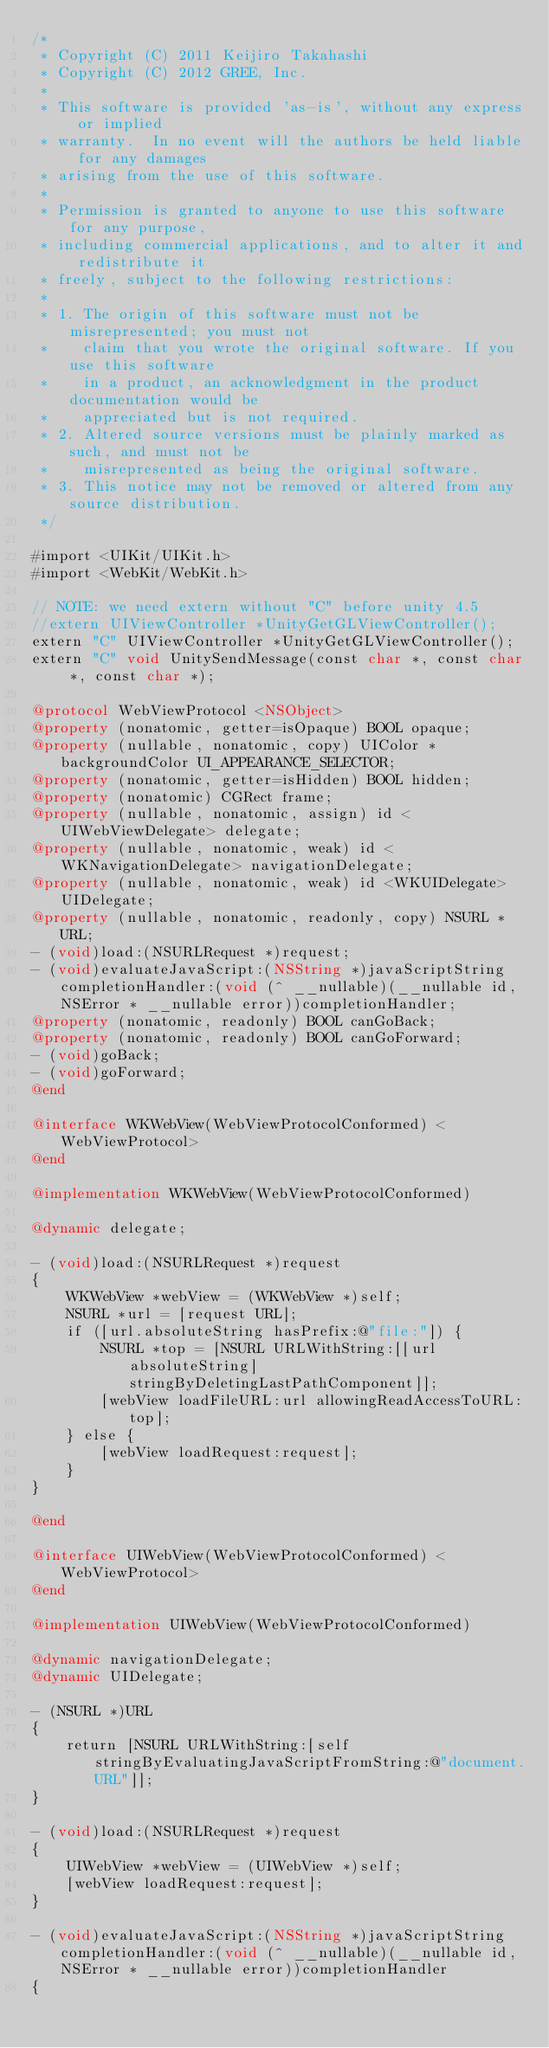Convert code to text. <code><loc_0><loc_0><loc_500><loc_500><_ObjectiveC_>/*
 * Copyright (C) 2011 Keijiro Takahashi
 * Copyright (C) 2012 GREE, Inc.
 *
 * This software is provided 'as-is', without any express or implied
 * warranty.  In no event will the authors be held liable for any damages
 * arising from the use of this software.
 *
 * Permission is granted to anyone to use this software for any purpose,
 * including commercial applications, and to alter it and redistribute it
 * freely, subject to the following restrictions:
 *
 * 1. The origin of this software must not be misrepresented; you must not
 *    claim that you wrote the original software. If you use this software
 *    in a product, an acknowledgment in the product documentation would be
 *    appreciated but is not required.
 * 2. Altered source versions must be plainly marked as such, and must not be
 *    misrepresented as being the original software.
 * 3. This notice may not be removed or altered from any source distribution.
 */

#import <UIKit/UIKit.h>
#import <WebKit/WebKit.h>

// NOTE: we need extern without "C" before unity 4.5
//extern UIViewController *UnityGetGLViewController();
extern "C" UIViewController *UnityGetGLViewController();
extern "C" void UnitySendMessage(const char *, const char *, const char *);

@protocol WebViewProtocol <NSObject>
@property (nonatomic, getter=isOpaque) BOOL opaque;
@property (nullable, nonatomic, copy) UIColor *backgroundColor UI_APPEARANCE_SELECTOR;
@property (nonatomic, getter=isHidden) BOOL hidden;
@property (nonatomic) CGRect frame;
@property (nullable, nonatomic, assign) id <UIWebViewDelegate> delegate;
@property (nullable, nonatomic, weak) id <WKNavigationDelegate> navigationDelegate;
@property (nullable, nonatomic, weak) id <WKUIDelegate> UIDelegate;
@property (nullable, nonatomic, readonly, copy) NSURL *URL;
- (void)load:(NSURLRequest *)request;
- (void)evaluateJavaScript:(NSString *)javaScriptString completionHandler:(void (^ __nullable)(__nullable id, NSError * __nullable error))completionHandler;
@property (nonatomic, readonly) BOOL canGoBack;
@property (nonatomic, readonly) BOOL canGoForward;
- (void)goBack;
- (void)goForward;
@end

@interface WKWebView(WebViewProtocolConformed) <WebViewProtocol>
@end

@implementation WKWebView(WebViewProtocolConformed)

@dynamic delegate;

- (void)load:(NSURLRequest *)request
{
    WKWebView *webView = (WKWebView *)self;
    NSURL *url = [request URL];
    if ([url.absoluteString hasPrefix:@"file:"]) {
        NSURL *top = [NSURL URLWithString:[[url absoluteString] stringByDeletingLastPathComponent]];
        [webView loadFileURL:url allowingReadAccessToURL:top];
    } else {
        [webView loadRequest:request];
    }
}

@end

@interface UIWebView(WebViewProtocolConformed) <WebViewProtocol>
@end

@implementation UIWebView(WebViewProtocolConformed)

@dynamic navigationDelegate;
@dynamic UIDelegate;

- (NSURL *)URL
{
    return [NSURL URLWithString:[self stringByEvaluatingJavaScriptFromString:@"document.URL"]];
}

- (void)load:(NSURLRequest *)request
{
    UIWebView *webView = (UIWebView *)self;
    [webView loadRequest:request];
}

- (void)evaluateJavaScript:(NSString *)javaScriptString completionHandler:(void (^ __nullable)(__nullable id, NSError * __nullable error))completionHandler
{</code> 